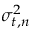Convert formula to latex. <formula><loc_0><loc_0><loc_500><loc_500>\sigma _ { t , n } ^ { 2 }</formula> 